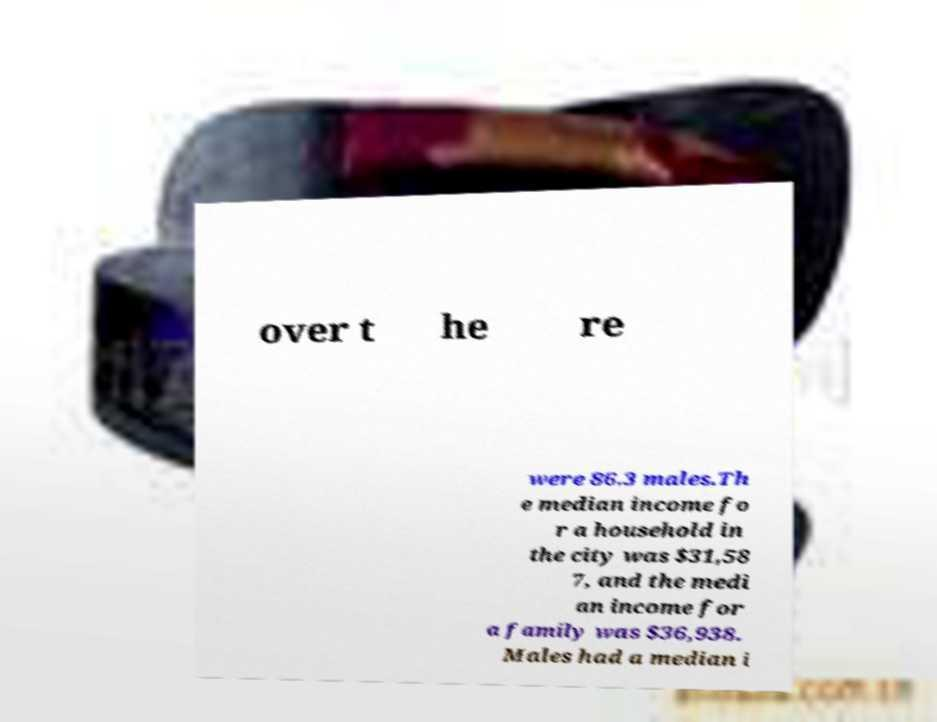Please read and relay the text visible in this image. What does it say? over t he re were 86.3 males.Th e median income fo r a household in the city was $31,58 7, and the medi an income for a family was $36,938. Males had a median i 